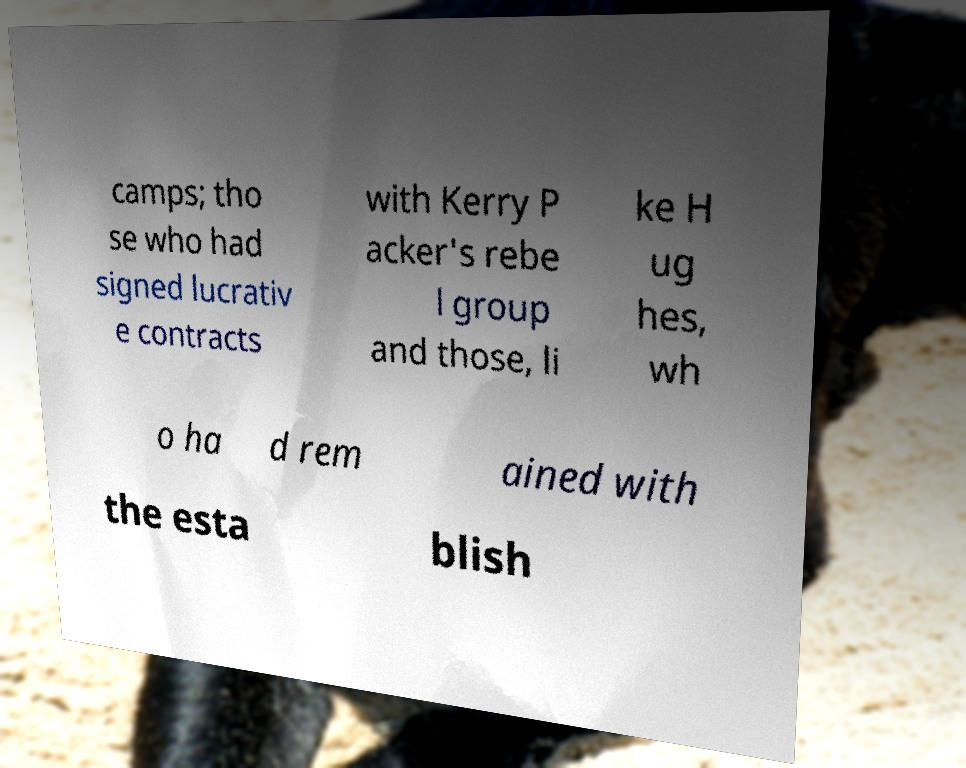Can you accurately transcribe the text from the provided image for me? camps; tho se who had signed lucrativ e contracts with Kerry P acker's rebe l group and those, li ke H ug hes, wh o ha d rem ained with the esta blish 